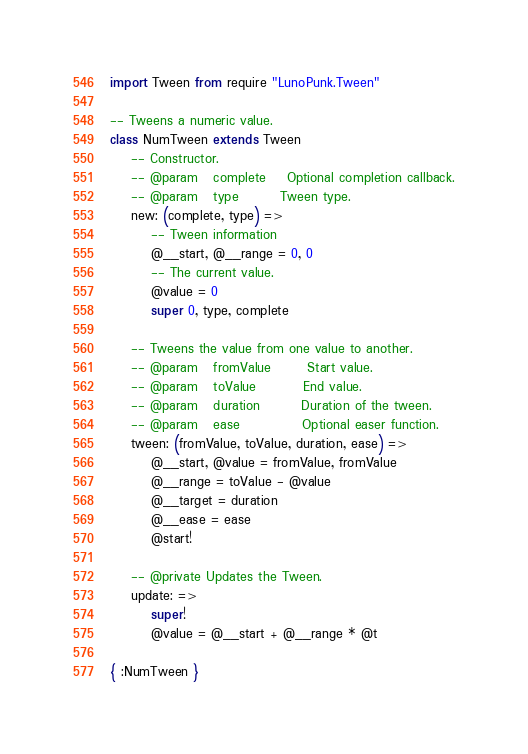Convert code to text. <code><loc_0><loc_0><loc_500><loc_500><_MoonScript_>import Tween from require "LunoPunk.Tween"

-- Tweens a numeric value.
class NumTween extends Tween
	-- Constructor.
	-- @param	complete	Optional completion callback.
	-- @param	type		Tween type.
	new: (complete, type) =>
		-- Tween information
		@__start, @__range = 0, 0
		-- The current value.
		@value = 0
		super 0, type, complete

	-- Tweens the value from one value to another.
	-- @param	fromValue		Start value.
	-- @param	toValue			End value.
	-- @param	duration		Duration of the tween.
	-- @param	ease			Optional easer function.
	tween: (fromValue, toValue, duration, ease) =>
		@__start, @value = fromValue, fromValue
		@__range = toValue - @value
		@__target = duration
		@__ease = ease
		@start!

	-- @private Updates the Tween.
	update: =>
		super!
		@value = @__start + @__range * @t

{ :NumTween }
</code> 